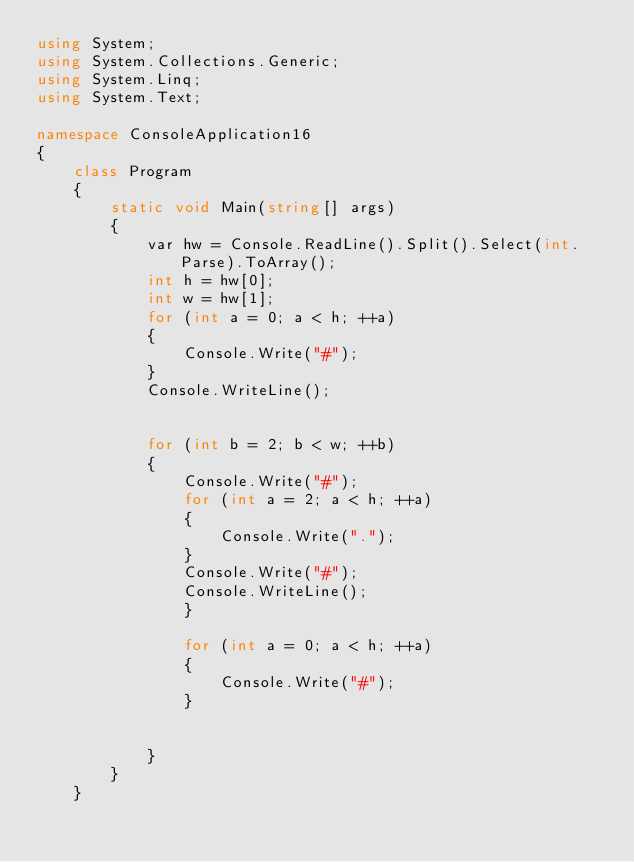Convert code to text. <code><loc_0><loc_0><loc_500><loc_500><_C#_>using System;
using System.Collections.Generic;
using System.Linq;
using System.Text;

namespace ConsoleApplication16
{
    class Program
    {
        static void Main(string[] args)
        {
            var hw = Console.ReadLine().Split().Select(int.Parse).ToArray();
            int h = hw[0];
            int w = hw[1];
            for (int a = 0; a < h; ++a)
            {
                Console.Write("#");
            }
            Console.WriteLine();
            

            for (int b = 2; b < w; ++b)
            {
                Console.Write("#");
                for (int a = 2; a < h; ++a)
                {
                    Console.Write(".");
                }
                Console.Write("#");
                Console.WriteLine();
                }

                for (int a = 0; a < h; ++a)
                {
                    Console.Write("#");
                }


            }
        }
    }</code> 